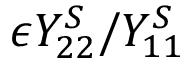<formula> <loc_0><loc_0><loc_500><loc_500>\epsilon Y _ { 2 2 } ^ { S } / Y _ { 1 1 } ^ { S }</formula> 